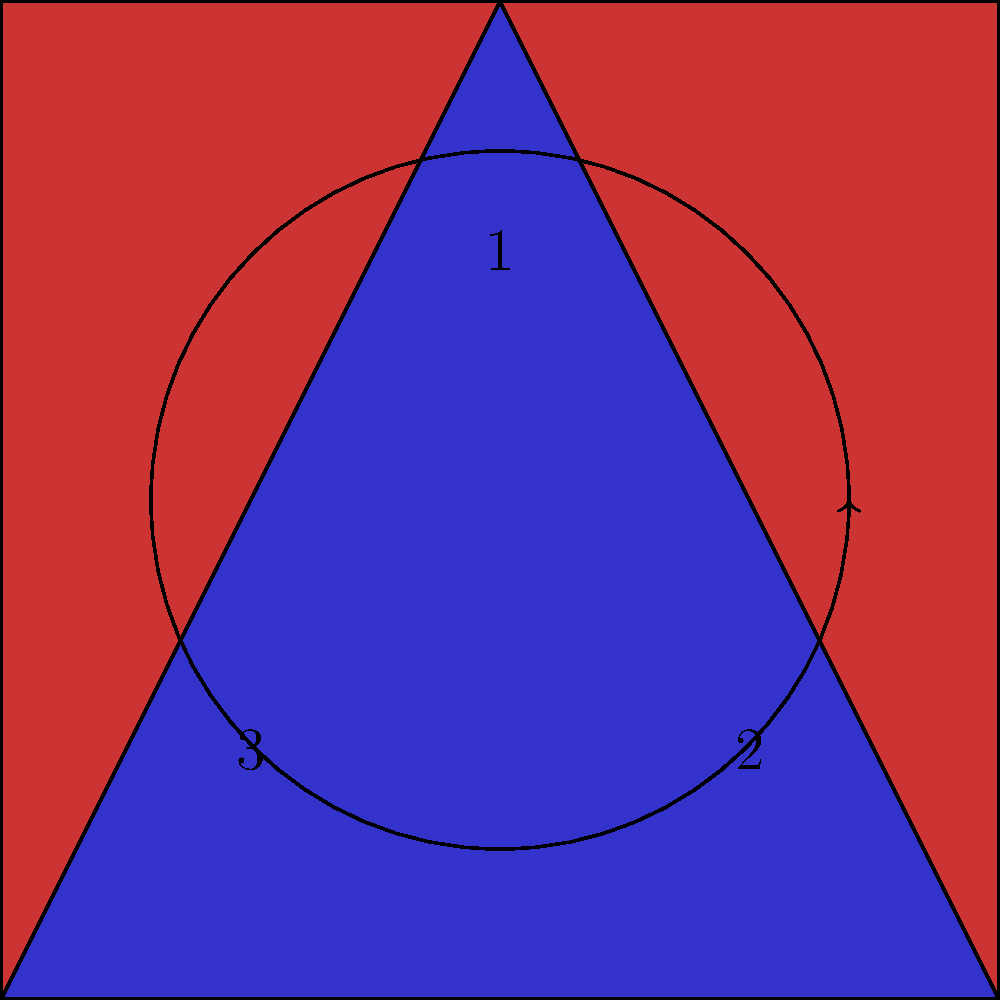In a Broadway production, a costume designer creates a pattern for a dress using the symmetry shown in the diagram. The pattern consists of a red square with a blue triangle inside, numbered as shown. How many elements are in the dihedral group that represents all possible symmetries of this costume pattern? To determine the number of elements in the dihedral group representing the symmetries of this costume pattern, we need to consider all possible rotations and reflections that preserve the pattern:

1. Rotations:
   - Identity (0° rotation)
   - 120° clockwise rotation
   - 240° clockwise rotation (equivalent to 120° counterclockwise)

2. Reflections:
   - Reflection across the line from vertex 1 to the midpoint of side 2-3
   - Reflection across the line from vertex 2 to the midpoint of side 1-3
   - Reflection across the line from vertex 3 to the midpoint of side 1-2

The total number of symmetries is the sum of rotations and reflections:
3 rotations + 3 reflections = 6 elements

This group is known as the dihedral group $D_3$ or $D_6$, depending on the notation used. It represents all symmetries of an equilateral triangle or a regular hexagon.
Answer: 6 